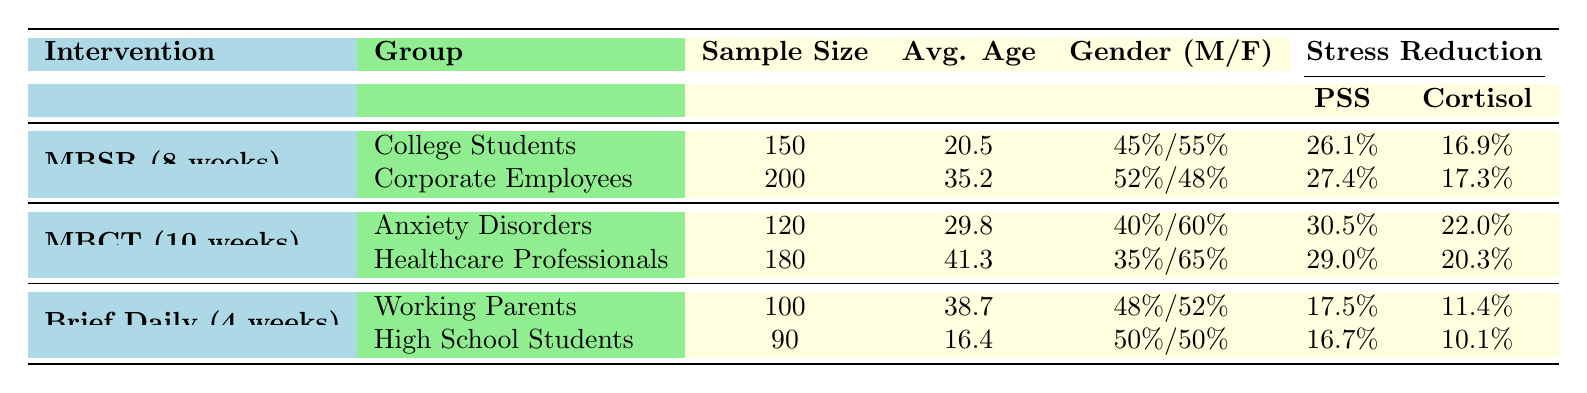What is the sample size for corporate employees in the MBSR intervention? The table states that for the MBSR intervention, the group of Corporate Employees has a sample size of 200 participants.
Answer: 200 What was the average age of the participants in the MBCT intervention for individuals with anxiety disorders? The table shows that the average age for participants in the MBCT intervention who have anxiety disorders is 29.8 years.
Answer: 29.8 Which mindfulness intervention had the highest percentage improvement in perceived stress scale for college students? From the table, the MBSR intervention shows a percentage improvement of 26.1%, which is higher than any other intervention for college students.
Answer: MBSR How much did cortisol levels improve for healthcare professionals in the MBCT intervention? The table indicates that cortisol levels improved from 15.3 to 12.2 in the MBCT intervention for healthcare professionals, resulting in a percentage improvement of 20.3%.
Answer: 20.3% What is the average percentage improvement in perceived stress scale across all interventions? The average is calculated by summing the percentage improvements for all groups: (26.1 + 27.4 + 30.5 + 29.0 + 17.5 + 16.7) = 147.2. There are 6 groups, so the average improvement is 147.2 / 6 = 24.53%.
Answer: 24.53% Is the sample size for high school students larger than that of working parents in the brief daily mindfulness practice? According to the table, high school students have a sample size of 90 while working parents have a sample size of 100. Thus, the sample size for high school students is not larger.
Answer: No Which intervention had the largest age average among participants? By comparing the average ages, the MBCT intervention for healthcare professionals has the largest average age at 41.3 years, which is higher than other interventions.
Answer: MBCT (Healthcare Professionals) What is the difference in perceived stress scale improvement between the college students and corporate employees in the MBSR intervention? The improvement for college students is 26.1%, and for corporate employees, it is 27.4%. The difference is calculated as 27.4 - 26.1 = 1.3%.
Answer: 1.3% Did working parents experience greater improvement in cortisol levels than high school students in the brief daily mindfulness practice? Working parents had a cortisol improvement of 11.4%, while high school students showed 10.1% improvement, indicating that working parents did indeed experience greater improvement.
Answer: Yes How does the average sample size compare among all interventions? For MBSR: (150 + 200) / 2 = 175; for MBCT: (120 + 180) / 2 = 150; for Brief Daily: (100 + 90) / 2 = 95. Overall average = (175 + 150 + 95) / 3 = 140.
Answer: 140 Are there more females than males in the corporate employees group of the MBSR intervention? The gender distribution shows 52% males and 48% females in the corporate employees group, indicating that there are more males than females.
Answer: No 